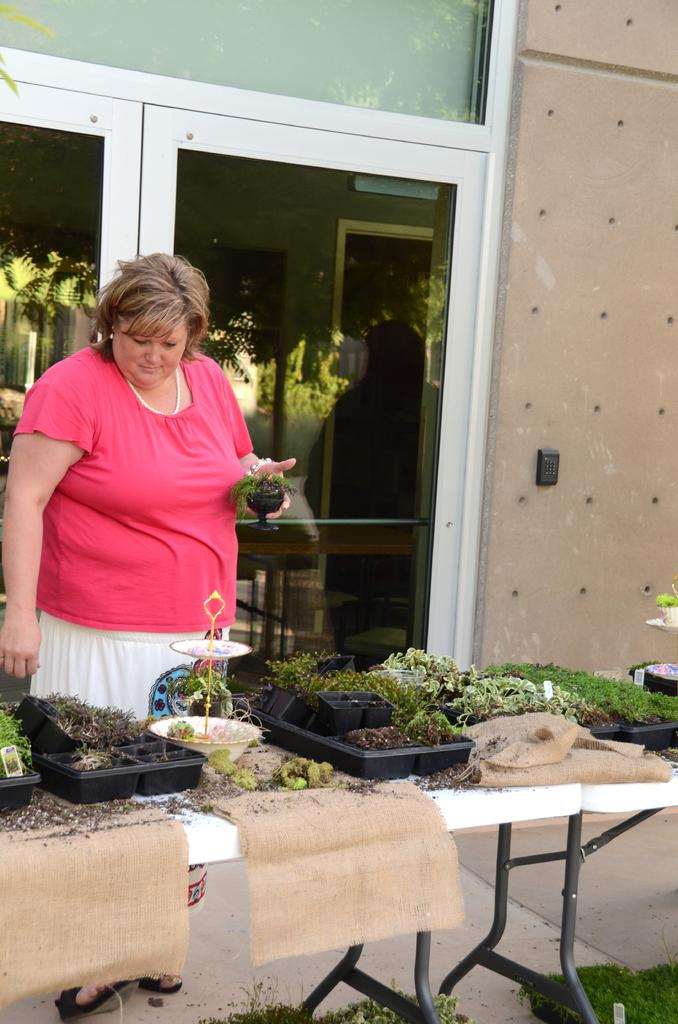Who is the main subject in the image? There is a woman in the image. What is the woman doing in the image? The woman is standing and holding a plant in her hand. What can be seen in the background of the image? There are other plants on a table and a wall in the background. Are there any architectural features visible in the background? Yes, there is a door in the background. What type of competition is the woman participating in, as seen in the image? There is no competition present in the image; it features a woman holding a plant and standing near other plants and a door. Can you tell me how many hammers are visible in the image? There are no hammers visible in the image. 